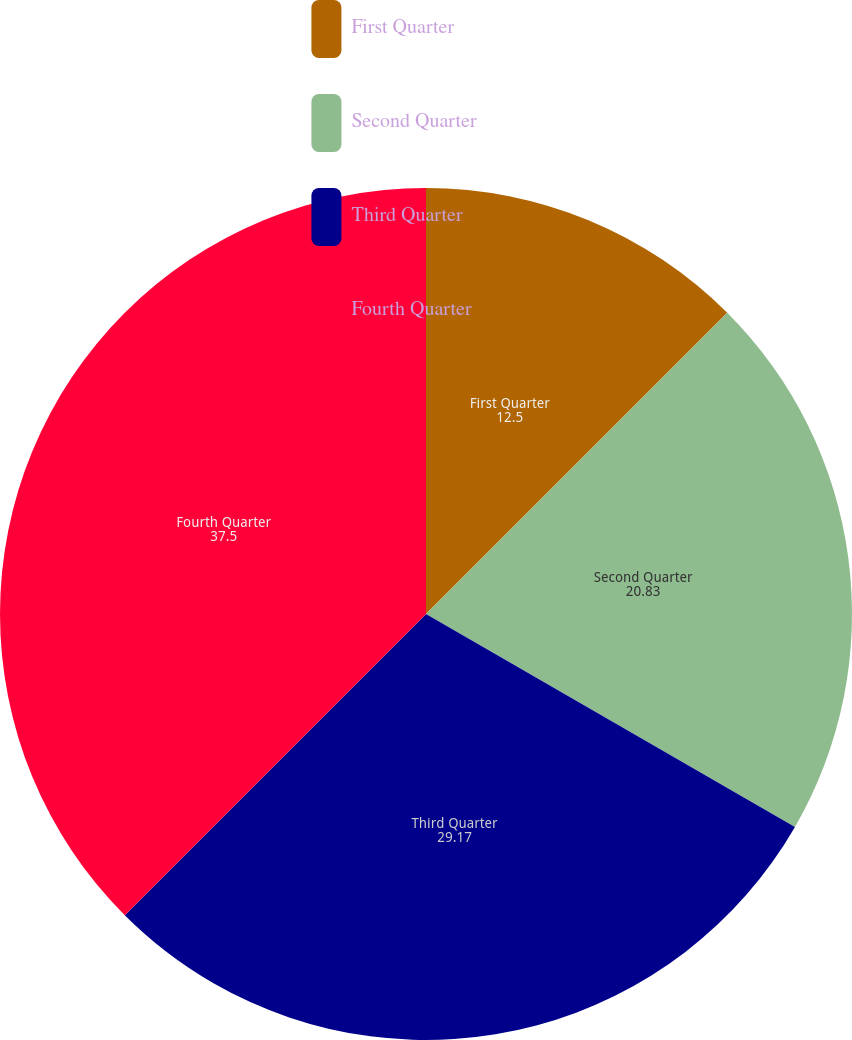<chart> <loc_0><loc_0><loc_500><loc_500><pie_chart><fcel>First Quarter<fcel>Second Quarter<fcel>Third Quarter<fcel>Fourth Quarter<nl><fcel>12.5%<fcel>20.83%<fcel>29.17%<fcel>37.5%<nl></chart> 